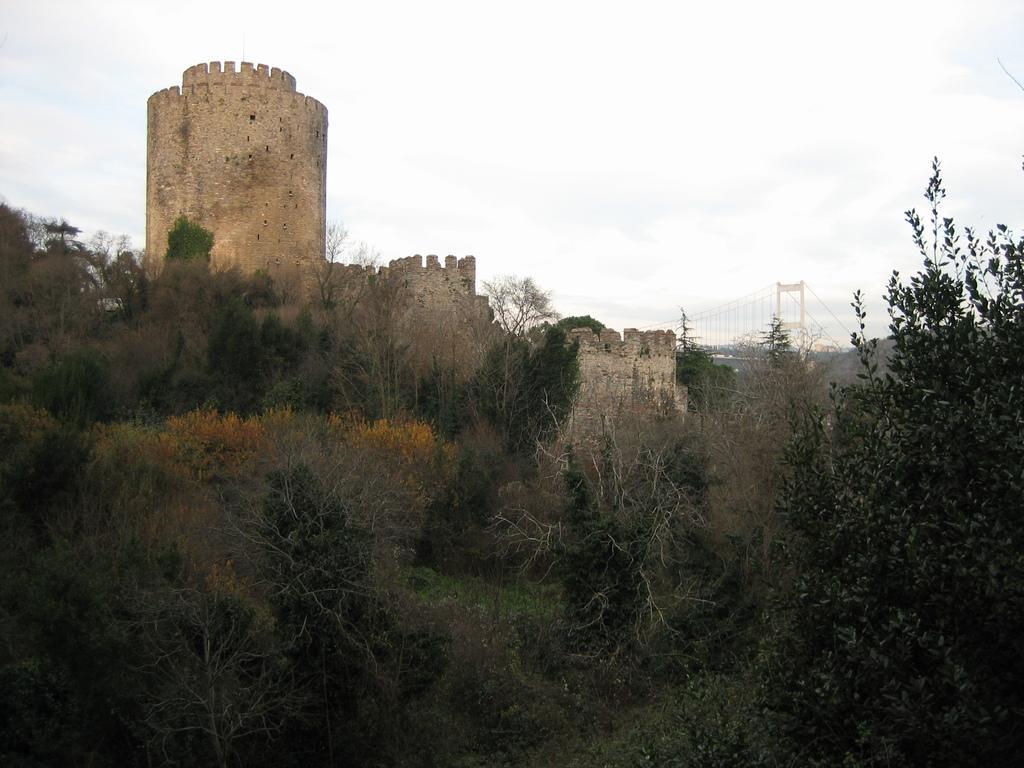Please provide a concise description of this image. In the picture we can see a hill with grass on it, we can see plants, trees and top of it, we can see a historical construction and besides it, we can see a bridge and in the background we can see a sky. 